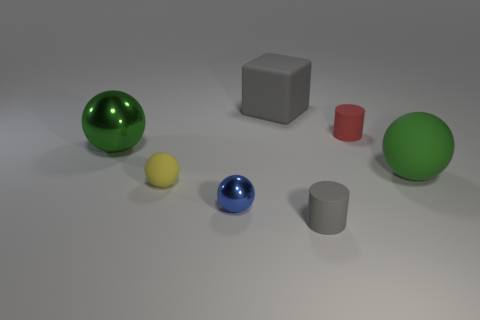There is a tiny matte thing that is on the left side of the big gray matte block; is its color the same as the matte thing that is in front of the tiny blue ball?
Provide a short and direct response. No. Is there anything else that is the same color as the big block?
Your answer should be very brief. Yes. Are there fewer gray matte cylinders left of the large gray matte thing than big things?
Your response must be concise. Yes. What number of green rubber objects are there?
Provide a short and direct response. 1. There is a tiny blue metal thing; does it have the same shape as the gray thing in front of the block?
Keep it short and to the point. No. Is the number of green balls in front of the gray matte cylinder less than the number of small blue balls in front of the small blue ball?
Make the answer very short. No. Are there any other things that are the same shape as the small blue object?
Give a very brief answer. Yes. Does the blue metal thing have the same shape as the large gray thing?
Your answer should be compact. No. Are there any other things that are the same material as the tiny red thing?
Your response must be concise. Yes. How big is the green metallic sphere?
Make the answer very short. Large. 